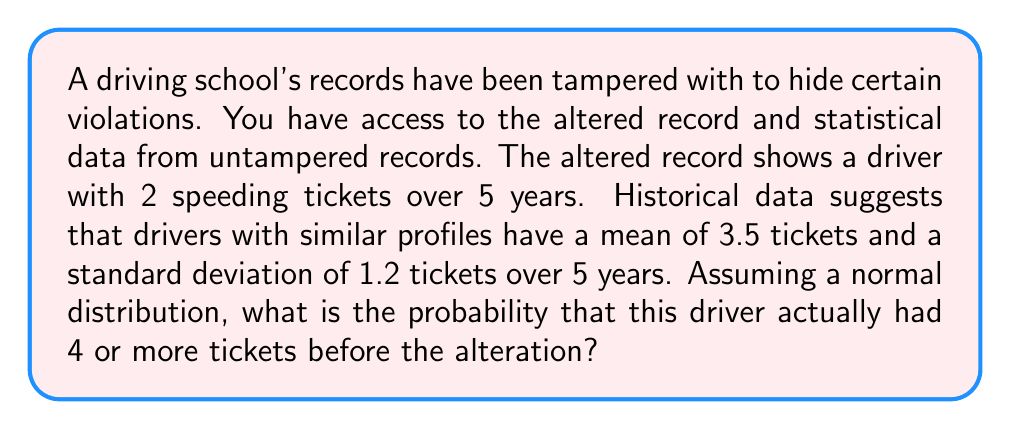Show me your answer to this math problem. To solve this problem, we'll use the standard normal distribution (z-score) approach:

1. Calculate the z-score for 4 tickets:
   $$ z = \frac{x - \mu}{\sigma} $$
   Where $x$ is the value we're interested in (4 tickets), $\mu$ is the mean (3.5 tickets), and $\sigma$ is the standard deviation (1.2 tickets).

   $$ z = \frac{4 - 3.5}{1.2} = \frac{0.5}{1.2} \approx 0.4167 $$

2. Look up the area to the right of this z-score in a standard normal table or use a calculator. This gives the probability of having 4 or more tickets.

3. For z = 0.4167, the area to the right is approximately 0.3384.

4. Convert to a percentage: 0.3384 * 100 = 33.84%

This means there's about a 33.84% chance that the driver actually had 4 or more tickets before the alteration, given the statistical data provided.
Answer: 33.84% 